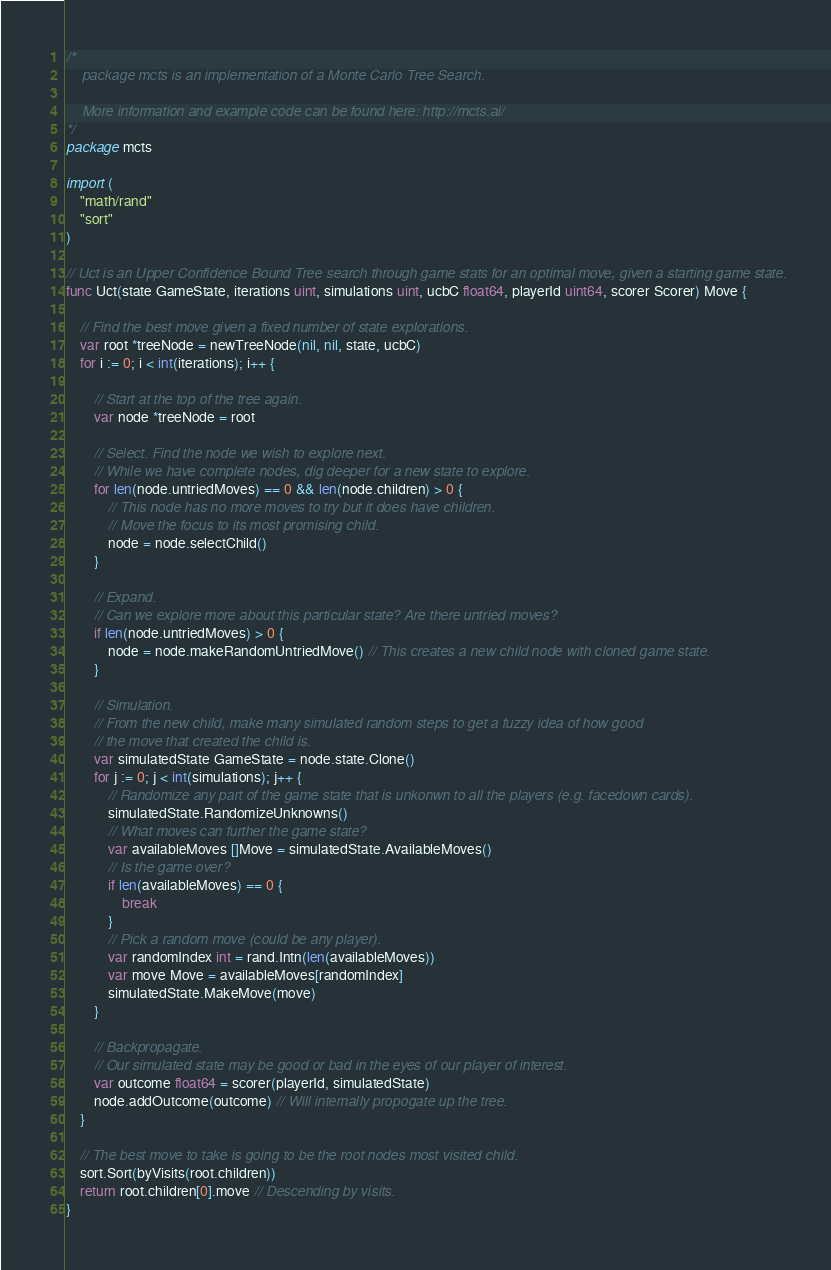Convert code to text. <code><loc_0><loc_0><loc_500><loc_500><_Go_>/*
	package mcts is an implementation of a Monte Carlo Tree Search.

	More information and example code can be found here: http://mcts.ai/
*/
package mcts

import (
	"math/rand"
	"sort"
)

// Uct is an Upper Confidence Bound Tree search through game stats for an optimal move, given a starting game state.
func Uct(state GameState, iterations uint, simulations uint, ucbC float64, playerId uint64, scorer Scorer) Move {

	// Find the best move given a fixed number of state explorations.
	var root *treeNode = newTreeNode(nil, nil, state, ucbC)
	for i := 0; i < int(iterations); i++ {

		// Start at the top of the tree again.
		var node *treeNode = root

		// Select. Find the node we wish to explore next.
		// While we have complete nodes, dig deeper for a new state to explore.
		for len(node.untriedMoves) == 0 && len(node.children) > 0 {
			// This node has no more moves to try but it does have children.
			// Move the focus to its most promising child.
			node = node.selectChild()
		}

		// Expand.
		// Can we explore more about this particular state? Are there untried moves?
		if len(node.untriedMoves) > 0 {
			node = node.makeRandomUntriedMove() // This creates a new child node with cloned game state.
		}

		// Simulation.
		// From the new child, make many simulated random steps to get a fuzzy idea of how good
		// the move that created the child is.
		var simulatedState GameState = node.state.Clone()
		for j := 0; j < int(simulations); j++ {
			// Randomize any part of the game state that is unkonwn to all the players (e.g. facedown cards).
			simulatedState.RandomizeUnknowns()
			// What moves can further the game state?
			var availableMoves []Move = simulatedState.AvailableMoves()
			// Is the game over?
			if len(availableMoves) == 0 {
				break
			}
			// Pick a random move (could be any player).
			var randomIndex int = rand.Intn(len(availableMoves))
			var move Move = availableMoves[randomIndex]
			simulatedState.MakeMove(move)
		}

		// Backpropagate.
		// Our simulated state may be good or bad in the eyes of our player of interest.
		var outcome float64 = scorer(playerId, simulatedState)
		node.addOutcome(outcome) // Will internally propogate up the tree.
	}

	// The best move to take is going to be the root nodes most visited child.
	sort.Sort(byVisits(root.children))
	return root.children[0].move // Descending by visits.
}
</code> 